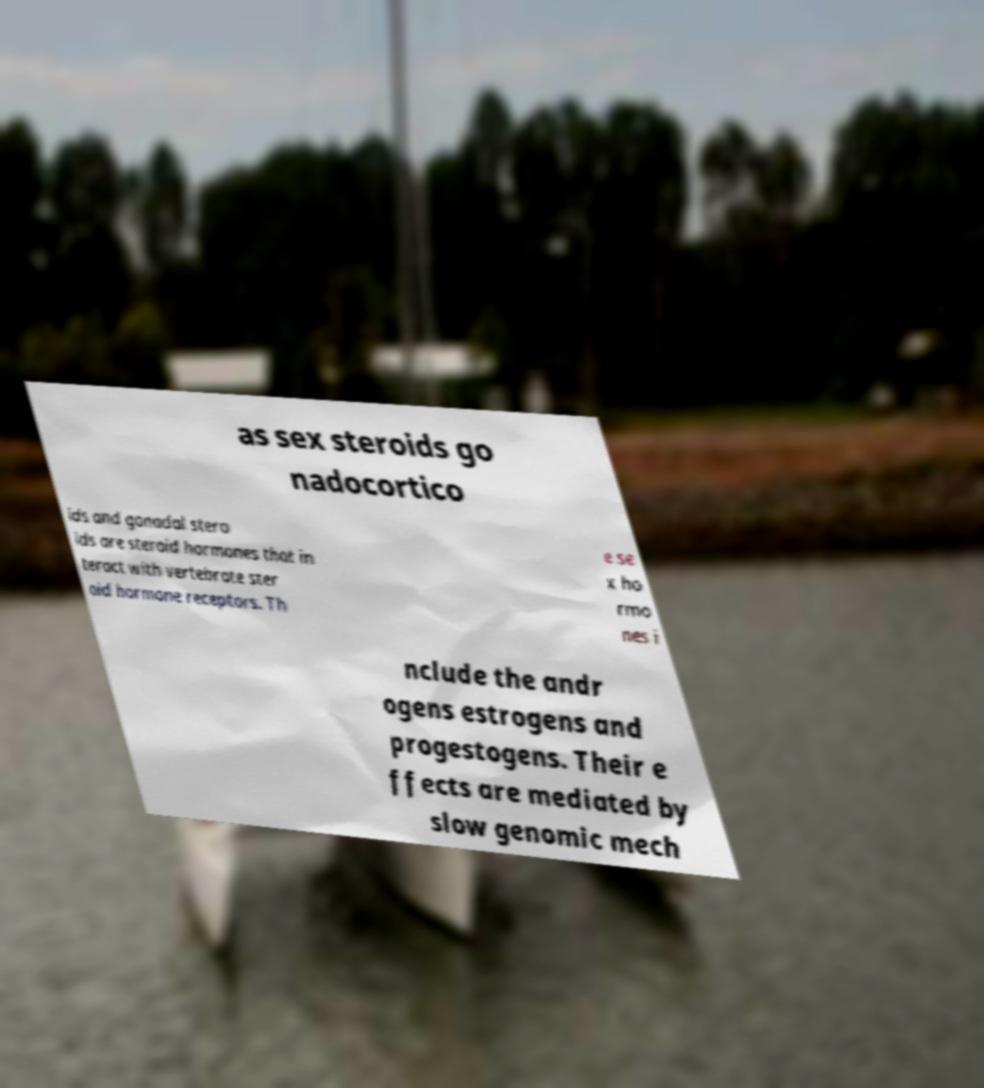Could you extract and type out the text from this image? as sex steroids go nadocortico ids and gonadal stero ids are steroid hormones that in teract with vertebrate ster oid hormone receptors. Th e se x ho rmo nes i nclude the andr ogens estrogens and progestogens. Their e ffects are mediated by slow genomic mech 